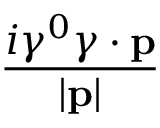Convert formula to latex. <formula><loc_0><loc_0><loc_500><loc_500>\frac { i \gamma ^ { 0 } \gamma \cdot p } { | p | }</formula> 